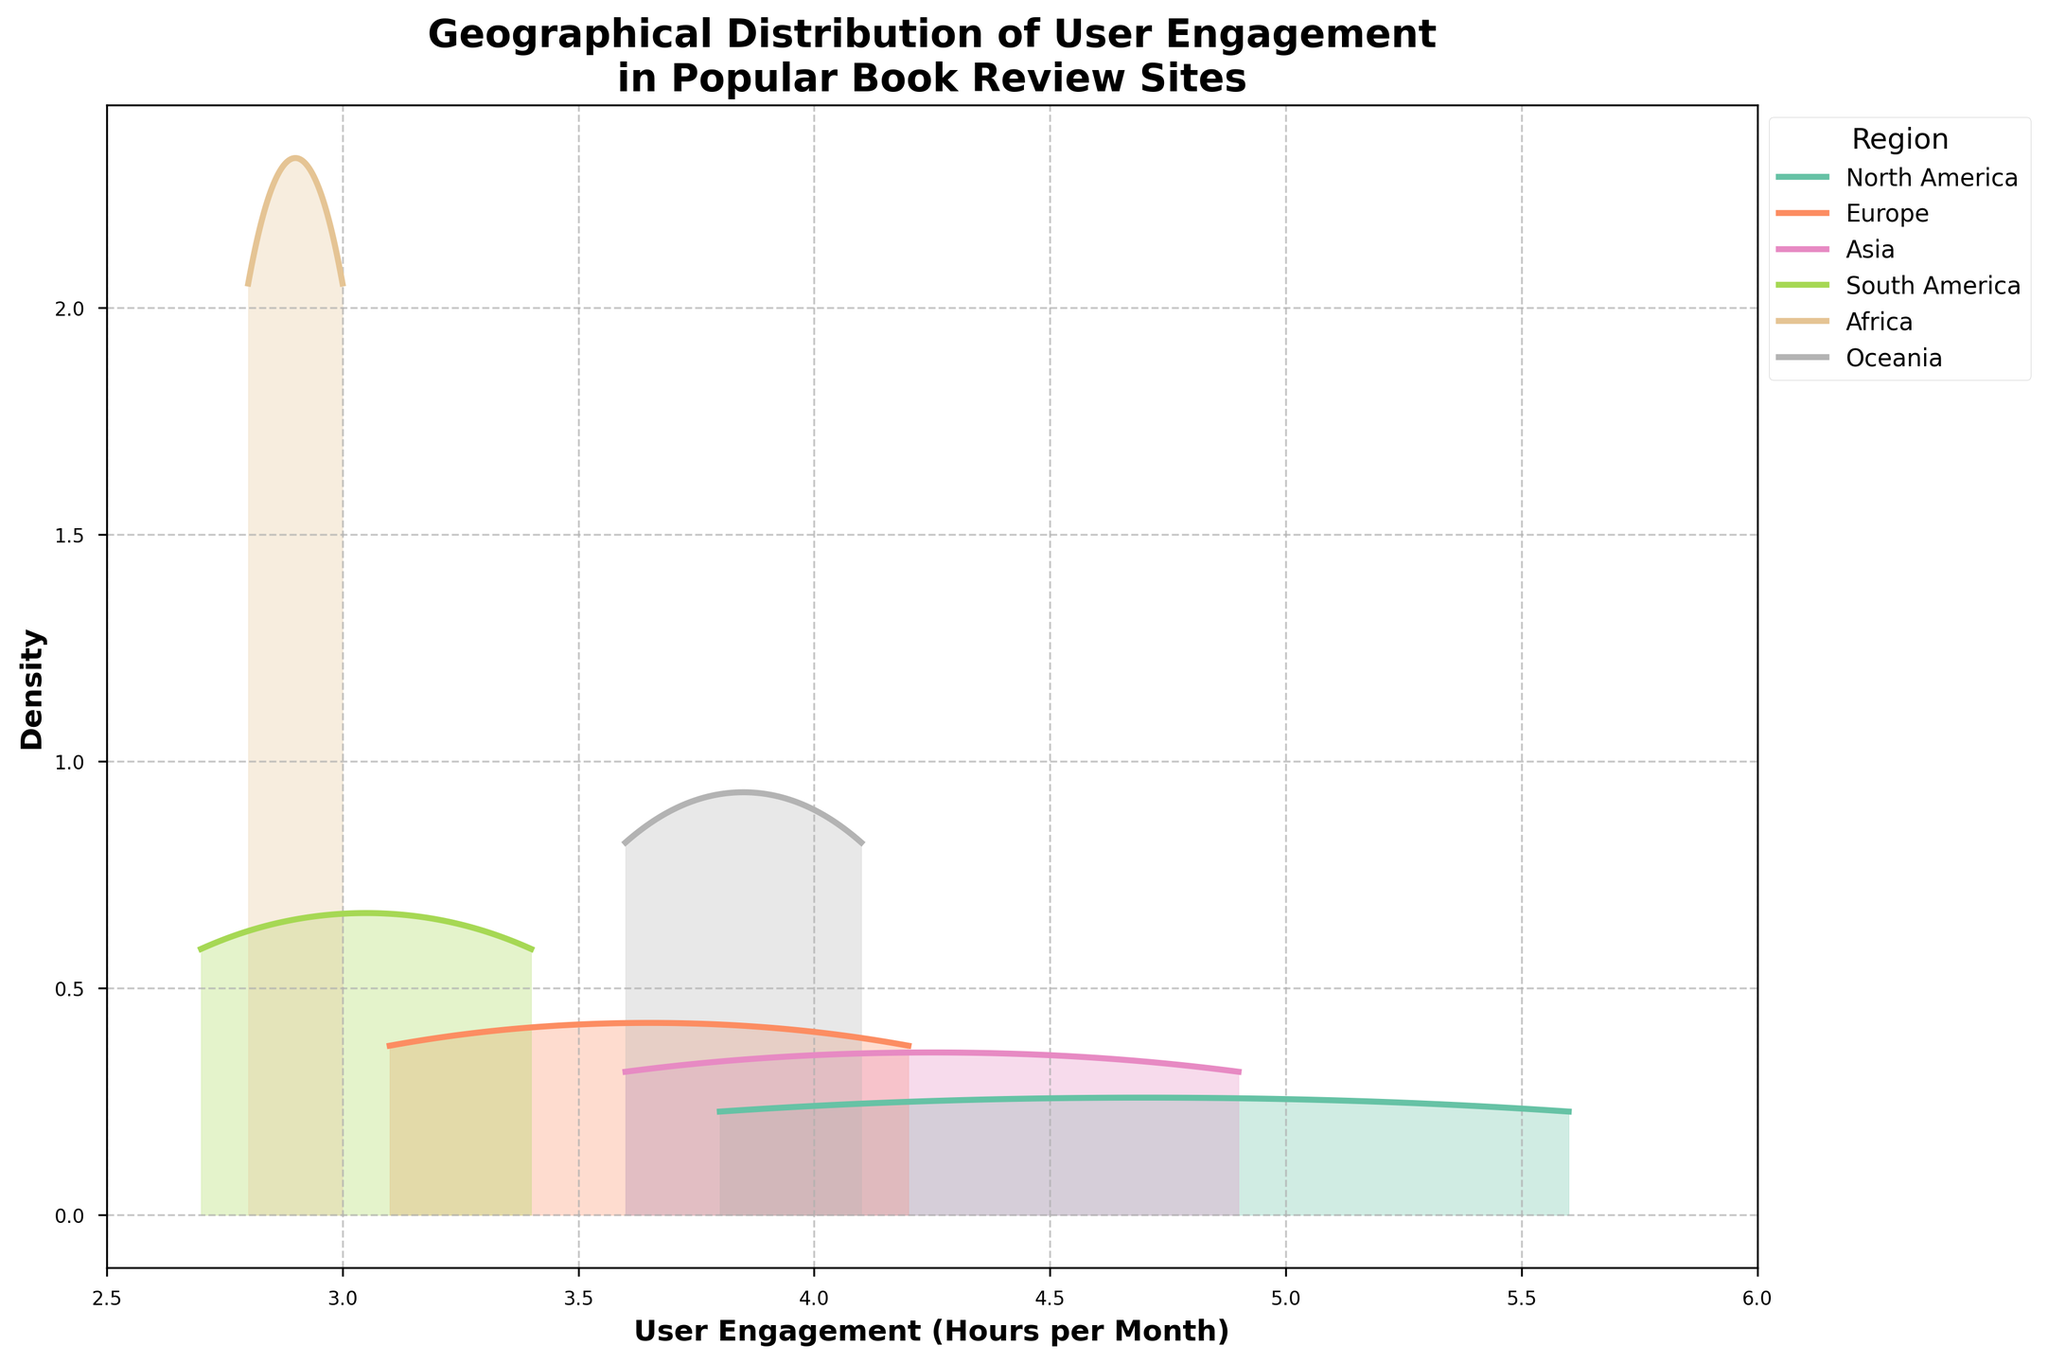What is the title of the plot? The title is typically located at the top of the plot. Here, it reads, "Geographical Distribution of User Engagement in Popular Book Review Sites".
Answer: Geographical Distribution of User Engagement in Popular Book Review Sites What are the units used on the x-axis of the plot? By inspecting the labels on the x-axis, we can see "User Engagement (Hours per Month)" is indicated, meaning the x-axis measures engagement in hours per month.
Answer: Hours per Month Which region shows the widest spread of user engagement levels? To find the region with the widest spread, we look for the density curve that spans the largest range on the x-axis, from the minimum to maximum value observed. Here, North America's curve notably has the widest spread, ranging approximately from 3.8 to 5.6 hours.
Answer: North America What regions have overlapping density curves, indicating similar user engagement distributions? Overlapping density curves suggest similar user engagement distributions. By examining the plot, Europe and Oceania have overlapping curves, indicating their user engagement distributions are quite similar.
Answer: Europe and Oceania Which region has the peak density at the highest user engagement hours? To answer this, we look for the highest peak (density mode) that is farthest to the right on the x-axis. The region with this characteristic is North America, peaking close to 5.6 hours.
Answer: North America What can we say about user engagement in South America based on the density plot? South America's distributions show a narrower spread compared to others, with peaks around lower engagement values (2.7 and 3.4). This reveals that user engagement here is lower and more concentrated around specific values.
Answer: Lower and concentrated around specific values Which region appears to have the least variability in user engagement? Least variability is indicated by a taller, narrower density curve. Here, Oceania shows the least variability since its density curves are taller and narrower compared to others.
Answer: Oceania How do the user engagement levels in Asia compare to those in Africa? By comparing the density curves for these two regions, we observe that Asia's distributions have higher peaks and are shifted to the right, indicating generally higher user engagement hours compared to Africa.
Answer: Asia has higher user engagement levels compared to Africa What is the approximate range of user engagement hours for Europe? The range can be estimated by noting where Europe's density curve starts and ends along the x-axis, which spans from approximately 3.1 to 4.2 hours.
Answer: 3.1 to 4.2 hours Is it possible to find the exact number of data points for each region from the plot? A density plot shows the distribution and shape but does not indicate the exact number of data points. Therefore, while we can deduce qualitative information, the exact number of points isn't available from the plot alone.
Answer: No 